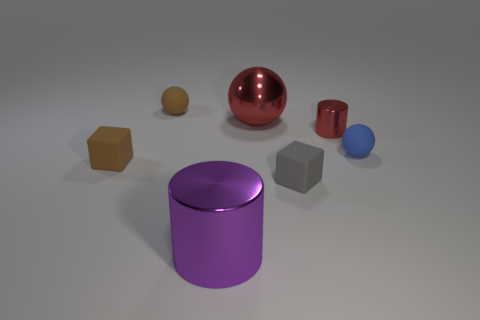Subtract 1 cubes. How many cubes are left? 1 Add 1 big green rubber objects. How many objects exist? 8 Subtract all red cylinders. How many cylinders are left? 1 Subtract all metallic balls. How many balls are left? 2 Subtract 0 purple balls. How many objects are left? 7 Subtract all blocks. How many objects are left? 5 Subtract all gray blocks. Subtract all cyan balls. How many blocks are left? 1 Subtract all brown cubes. How many purple cylinders are left? 1 Subtract all rubber balls. Subtract all red shiny objects. How many objects are left? 3 Add 7 purple shiny things. How many purple shiny things are left? 8 